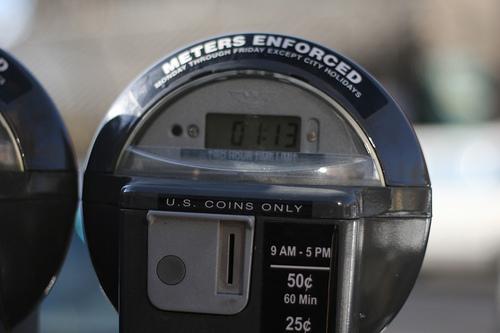What kind of coins does meter take?
Give a very brief answer. Us coins. How much does this meter cost per hour?
Keep it brief. 50 cents. Is there money in the meter?
Quick response, please. Yes. Is there a store in the background?
Give a very brief answer. No. How many minutes left?
Give a very brief answer. 73. What time is it?
Be succinct. 1:13. 